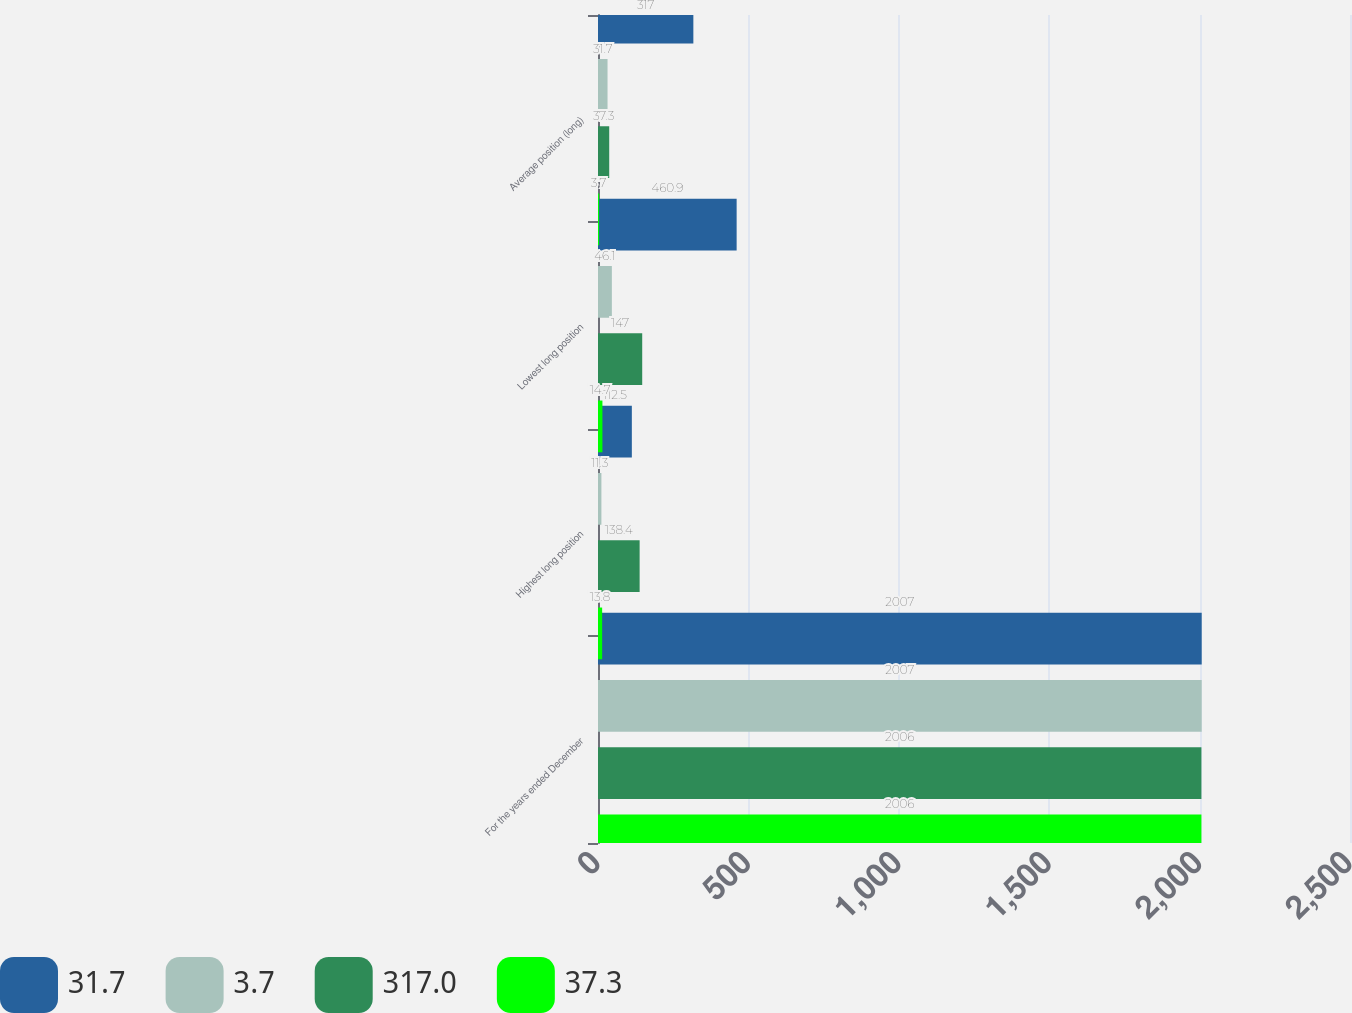<chart> <loc_0><loc_0><loc_500><loc_500><stacked_bar_chart><ecel><fcel>For the years ended December<fcel>Highest long position<fcel>Lowest long position<fcel>Average position (long)<nl><fcel>31.7<fcel>2007<fcel>112.5<fcel>460.9<fcel>317<nl><fcel>3.7<fcel>2007<fcel>11.3<fcel>46.1<fcel>31.7<nl><fcel>317<fcel>2006<fcel>138.4<fcel>147<fcel>37.3<nl><fcel>37.3<fcel>2006<fcel>13.8<fcel>14.7<fcel>3.7<nl></chart> 